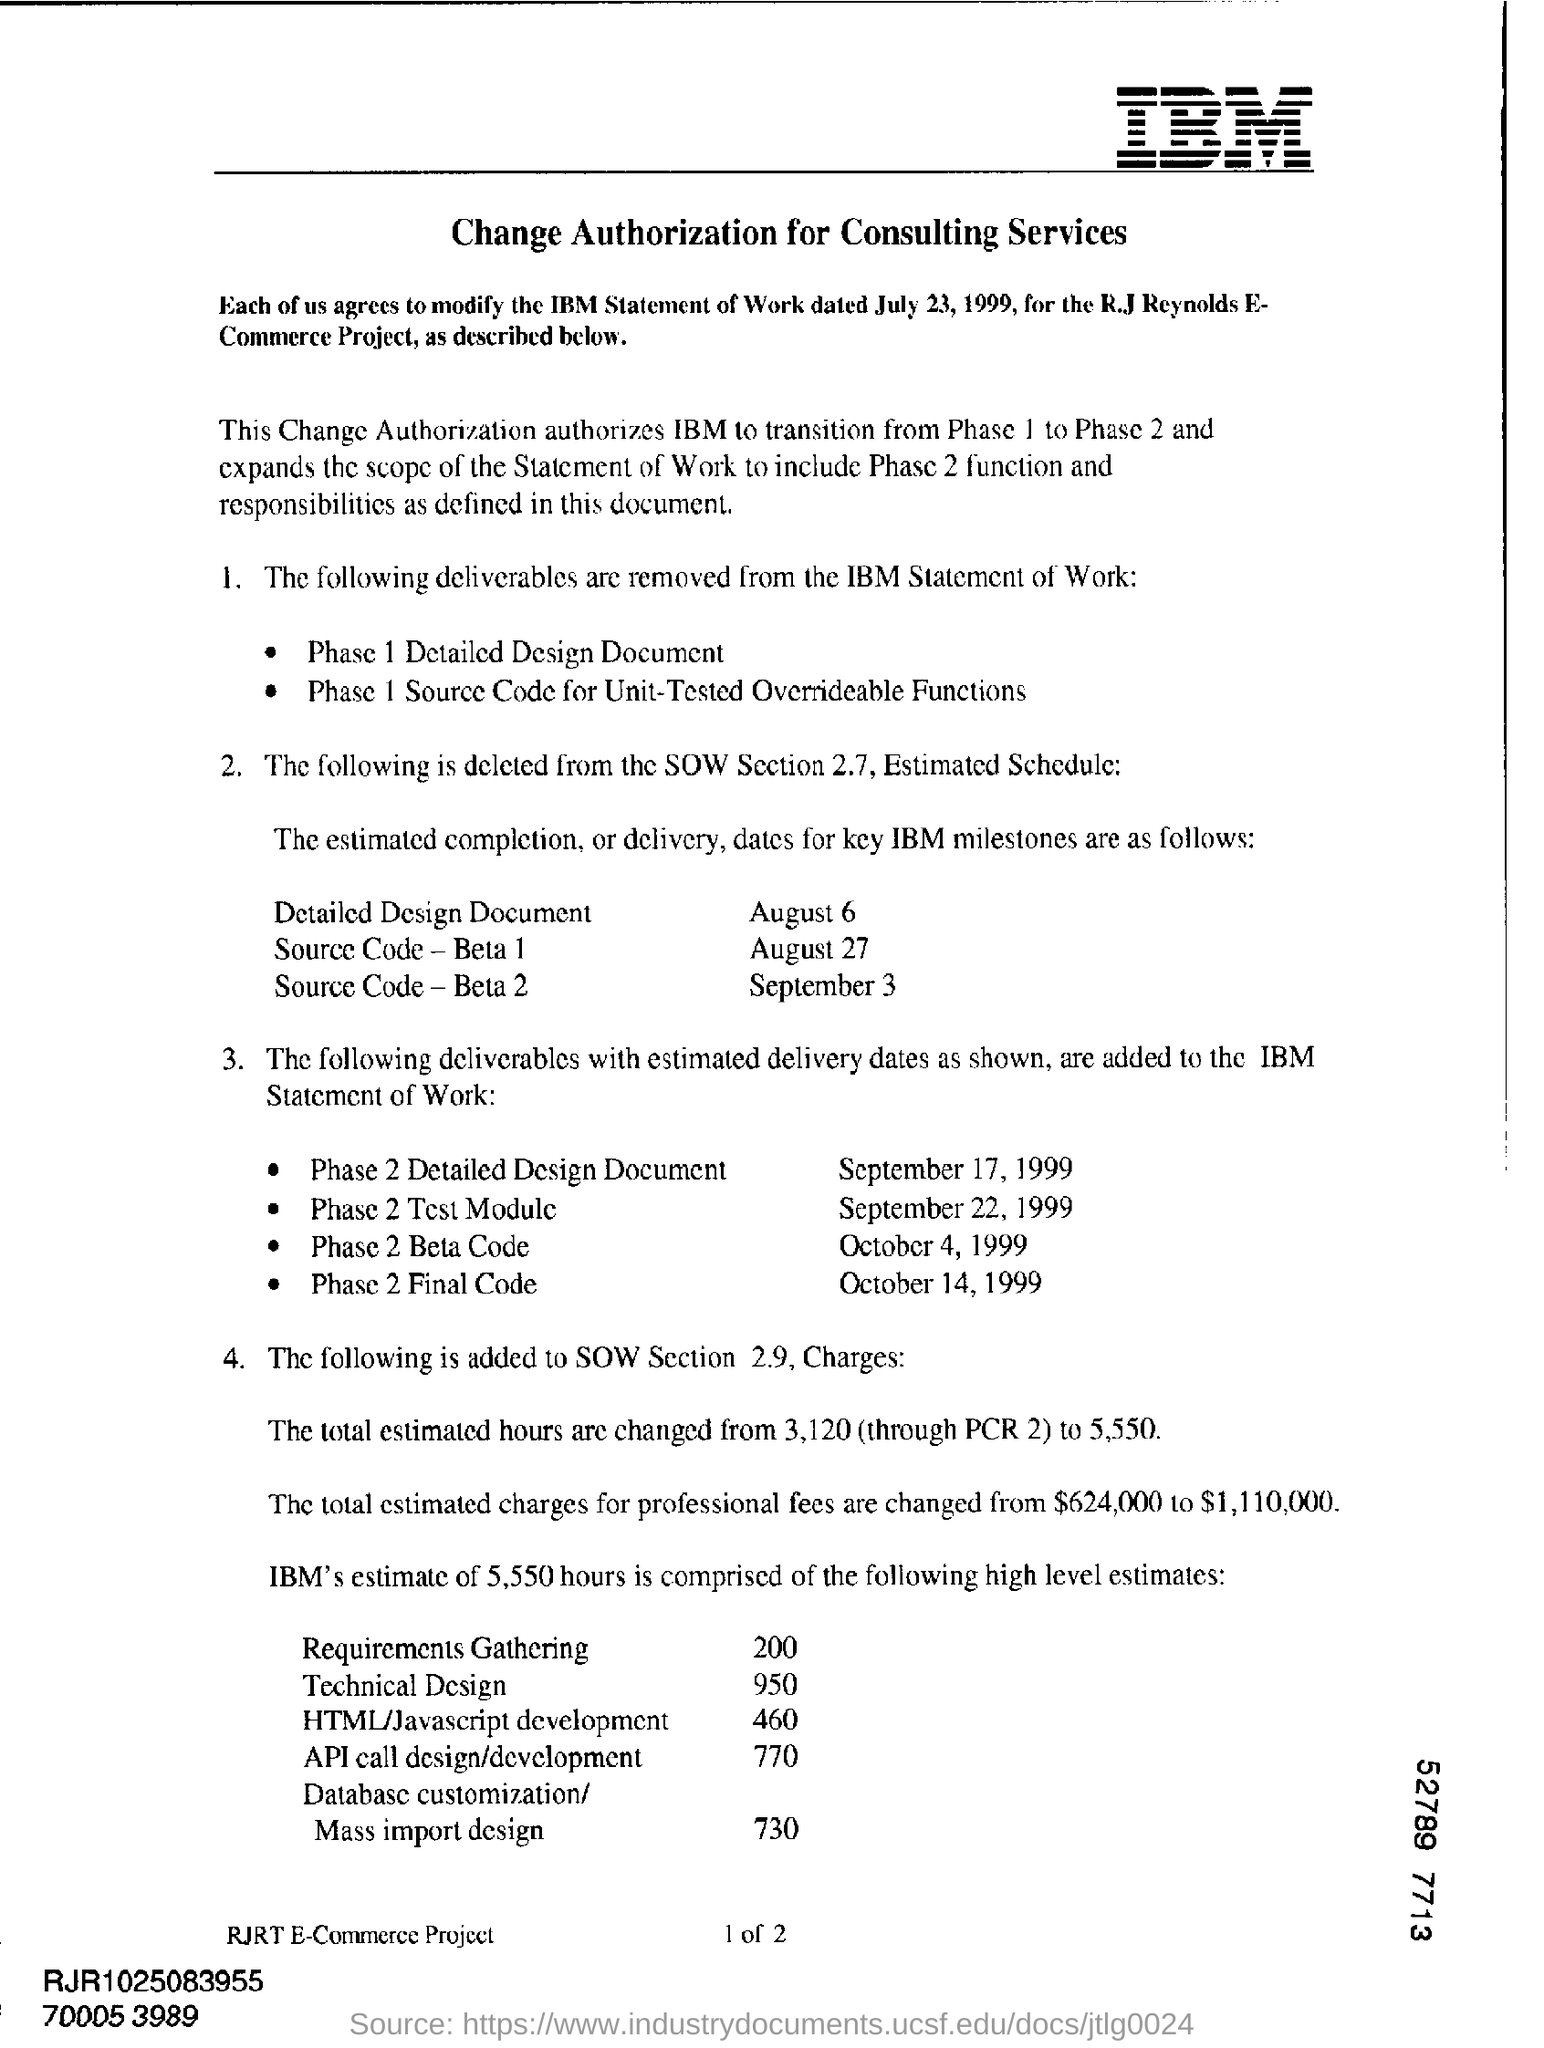When is the estimated delivery date for Phase 2 Test Module?
Your answer should be compact. September 22, 1999. Which deliverable has to be delivered on October 4, 1999?
Give a very brief answer. Phase 2 Beta Code. When is the completion of Source Code- Beta 1?
Your response must be concise. August 27. What is the new total estimated charges for professional fees?
Your answer should be very brief. $1,110,000. 